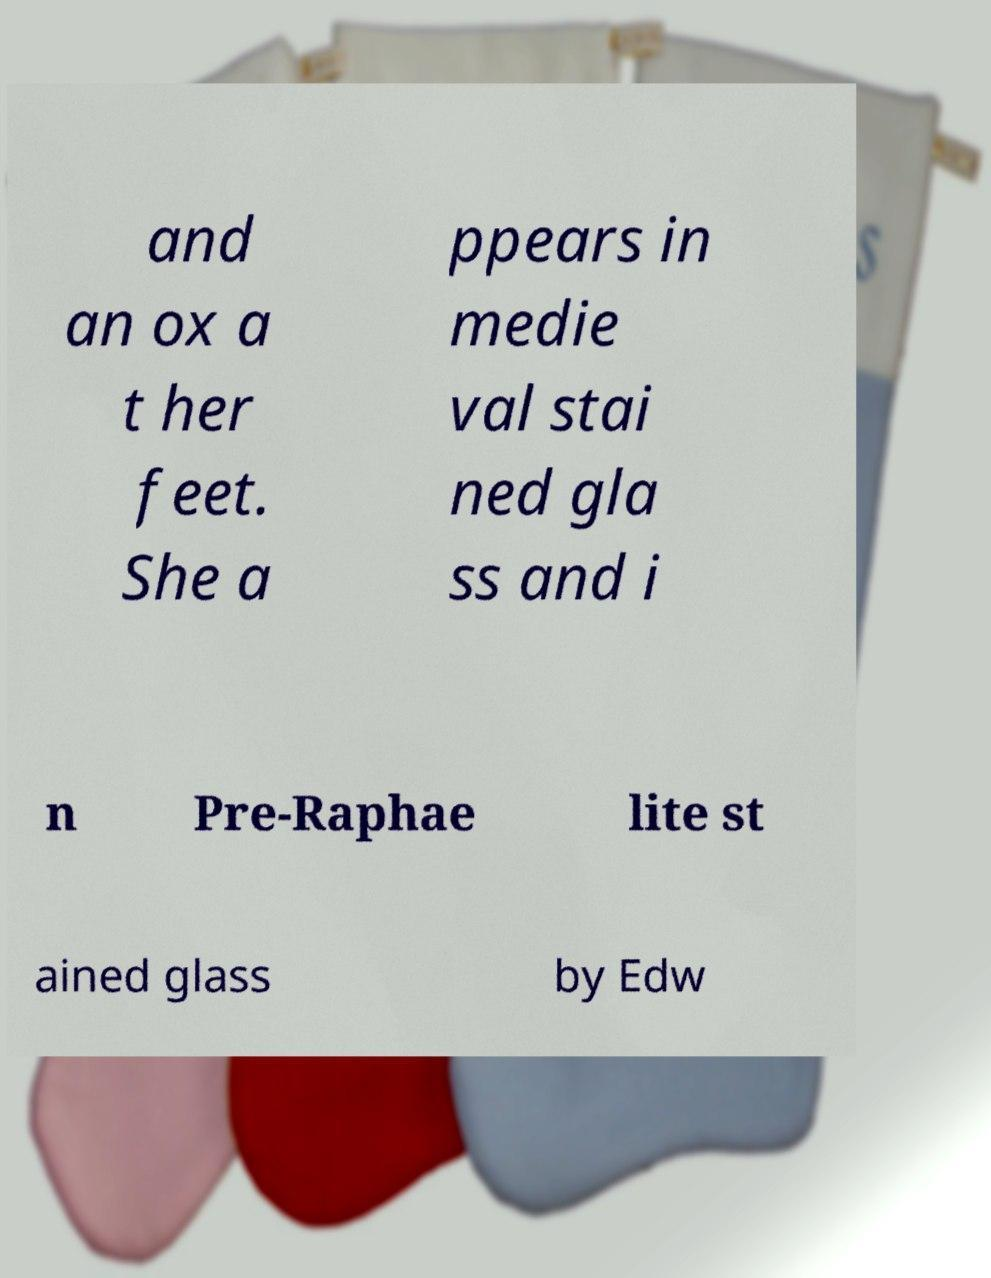What messages or text are displayed in this image? I need them in a readable, typed format. and an ox a t her feet. She a ppears in medie val stai ned gla ss and i n Pre-Raphae lite st ained glass by Edw 